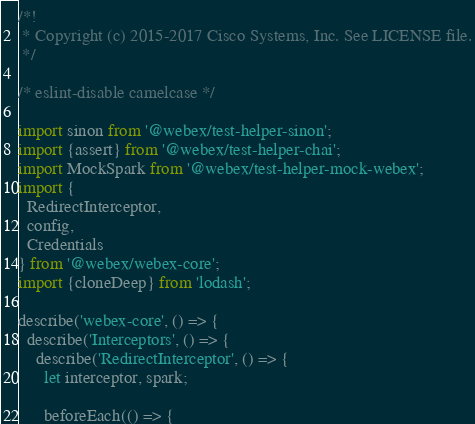Convert code to text. <code><loc_0><loc_0><loc_500><loc_500><_JavaScript_>/*!
 * Copyright (c) 2015-2017 Cisco Systems, Inc. See LICENSE file.
 */

/* eslint-disable camelcase */

import sinon from '@webex/test-helper-sinon';
import {assert} from '@webex/test-helper-chai';
import MockSpark from '@webex/test-helper-mock-webex';
import {
  RedirectInterceptor,
  config,
  Credentials
} from '@webex/webex-core';
import {cloneDeep} from 'lodash';

describe('webex-core', () => {
  describe('Interceptors', () => {
    describe('RedirectInterceptor', () => {
      let interceptor, spark;

      beforeEach(() => {</code> 